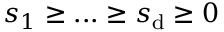Convert formula to latex. <formula><loc_0><loc_0><loc_500><loc_500>s _ { 1 } \geq \dots \geq s _ { d } \geq 0</formula> 